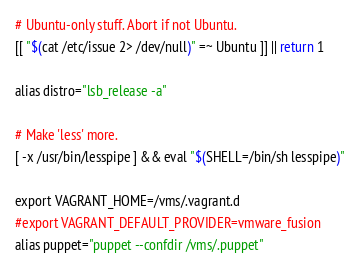Convert code to text. <code><loc_0><loc_0><loc_500><loc_500><_Bash_># Ubuntu-only stuff. Abort if not Ubuntu.
[[ "$(cat /etc/issue 2> /dev/null)" =~ Ubuntu ]] || return 1

alias distro="lsb_release -a"

# Make 'less' more.
[ -x /usr/bin/lesspipe ] && eval "$(SHELL=/bin/sh lesspipe)"

export VAGRANT_HOME=/vms/.vagrant.d
#export VAGRANT_DEFAULT_PROVIDER=vmware_fusion
alias puppet="puppet --confdir /vms/.puppet"</code> 